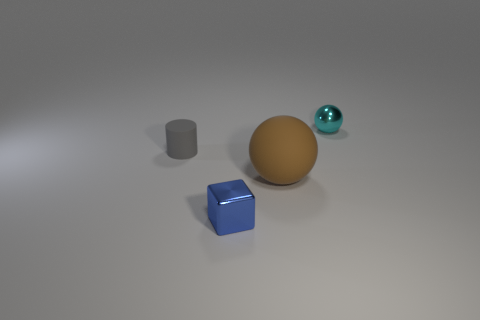What number of small gray matte things are there?
Offer a very short reply. 1. Is the material of the ball on the left side of the small cyan metallic object the same as the blue object?
Ensure brevity in your answer.  No. Is there any other thing that has the same material as the big object?
Ensure brevity in your answer.  Yes. There is a sphere to the left of the small metal thing that is behind the tiny gray rubber cylinder; what number of blue metallic cubes are to the right of it?
Keep it short and to the point. 0. What size is the cyan thing?
Provide a short and direct response. Small. Is the large object the same color as the shiny sphere?
Your answer should be compact. No. What size is the matte object that is on the right side of the tiny blue object?
Offer a very short reply. Large. There is a shiny object that is on the left side of the small cyan thing; is its color the same as the tiny shiny object right of the metal cube?
Your response must be concise. No. How many other objects are the same shape as the small blue thing?
Your answer should be compact. 0. Is the number of big brown balls that are left of the small blue block the same as the number of cyan shiny spheres that are to the left of the tiny cylinder?
Offer a terse response. Yes. 